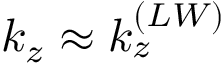<formula> <loc_0><loc_0><loc_500><loc_500>k _ { z } \approx k _ { z } ^ { ( L W ) }</formula> 